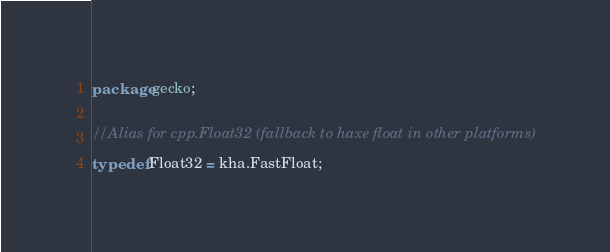Convert code to text. <code><loc_0><loc_0><loc_500><loc_500><_Haxe_>package gecko;

//Alias for cpp.Float32 (fallback to haxe float in other platforms)
typedef Float32 = kha.FastFloat;</code> 